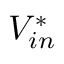<formula> <loc_0><loc_0><loc_500><loc_500>V _ { i n } ^ { * }</formula> 